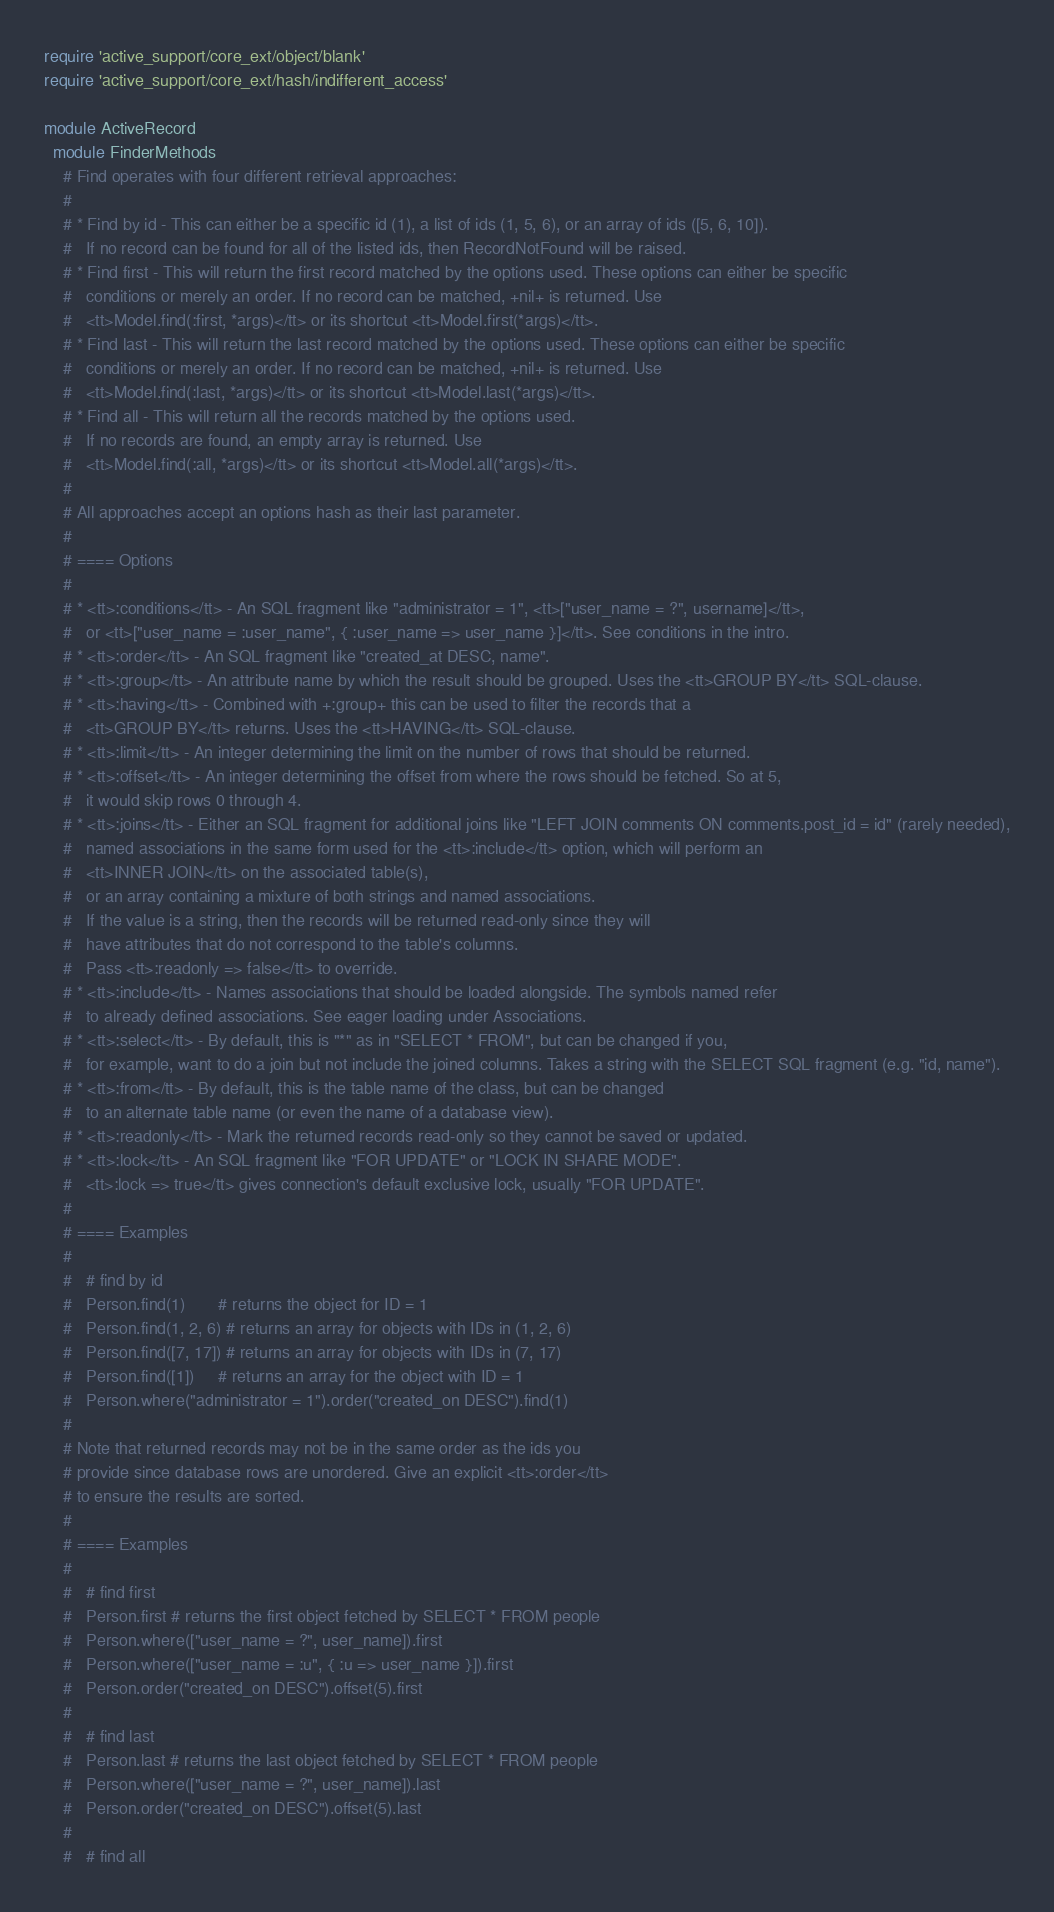<code> <loc_0><loc_0><loc_500><loc_500><_Ruby_>require 'active_support/core_ext/object/blank'
require 'active_support/core_ext/hash/indifferent_access'

module ActiveRecord
  module FinderMethods
    # Find operates with four different retrieval approaches:
    #
    # * Find by id - This can either be a specific id (1), a list of ids (1, 5, 6), or an array of ids ([5, 6, 10]).
    #   If no record can be found for all of the listed ids, then RecordNotFound will be raised.
    # * Find first - This will return the first record matched by the options used. These options can either be specific
    #   conditions or merely an order. If no record can be matched, +nil+ is returned. Use
    #   <tt>Model.find(:first, *args)</tt> or its shortcut <tt>Model.first(*args)</tt>.
    # * Find last - This will return the last record matched by the options used. These options can either be specific
    #   conditions or merely an order. If no record can be matched, +nil+ is returned. Use
    #   <tt>Model.find(:last, *args)</tt> or its shortcut <tt>Model.last(*args)</tt>.
    # * Find all - This will return all the records matched by the options used.
    #   If no records are found, an empty array is returned. Use
    #   <tt>Model.find(:all, *args)</tt> or its shortcut <tt>Model.all(*args)</tt>.
    #
    # All approaches accept an options hash as their last parameter.
    #
    # ==== Options
    #
    # * <tt>:conditions</tt> - An SQL fragment like "administrator = 1", <tt>["user_name = ?", username]</tt>,
    #   or <tt>["user_name = :user_name", { :user_name => user_name }]</tt>. See conditions in the intro.
    # * <tt>:order</tt> - An SQL fragment like "created_at DESC, name".
    # * <tt>:group</tt> - An attribute name by which the result should be grouped. Uses the <tt>GROUP BY</tt> SQL-clause.
    # * <tt>:having</tt> - Combined with +:group+ this can be used to filter the records that a
    #   <tt>GROUP BY</tt> returns. Uses the <tt>HAVING</tt> SQL-clause.
    # * <tt>:limit</tt> - An integer determining the limit on the number of rows that should be returned.
    # * <tt>:offset</tt> - An integer determining the offset from where the rows should be fetched. So at 5,
    #   it would skip rows 0 through 4.
    # * <tt>:joins</tt> - Either an SQL fragment for additional joins like "LEFT JOIN comments ON comments.post_id = id" (rarely needed),
    #   named associations in the same form used for the <tt>:include</tt> option, which will perform an
    #   <tt>INNER JOIN</tt> on the associated table(s),
    #   or an array containing a mixture of both strings and named associations.
    #   If the value is a string, then the records will be returned read-only since they will
    #   have attributes that do not correspond to the table's columns.
    #   Pass <tt>:readonly => false</tt> to override.
    # * <tt>:include</tt> - Names associations that should be loaded alongside. The symbols named refer
    #   to already defined associations. See eager loading under Associations.
    # * <tt>:select</tt> - By default, this is "*" as in "SELECT * FROM", but can be changed if you,
    #   for example, want to do a join but not include the joined columns. Takes a string with the SELECT SQL fragment (e.g. "id, name").
    # * <tt>:from</tt> - By default, this is the table name of the class, but can be changed
    #   to an alternate table name (or even the name of a database view).
    # * <tt>:readonly</tt> - Mark the returned records read-only so they cannot be saved or updated.
    # * <tt>:lock</tt> - An SQL fragment like "FOR UPDATE" or "LOCK IN SHARE MODE".
    #   <tt>:lock => true</tt> gives connection's default exclusive lock, usually "FOR UPDATE".
    #
    # ==== Examples
    #
    #   # find by id
    #   Person.find(1)       # returns the object for ID = 1
    #   Person.find(1, 2, 6) # returns an array for objects with IDs in (1, 2, 6)
    #   Person.find([7, 17]) # returns an array for objects with IDs in (7, 17)
    #   Person.find([1])     # returns an array for the object with ID = 1
    #   Person.where("administrator = 1").order("created_on DESC").find(1)
    #
    # Note that returned records may not be in the same order as the ids you
    # provide since database rows are unordered. Give an explicit <tt>:order</tt>
    # to ensure the results are sorted.
    #
    # ==== Examples
    #
    #   # find first
    #   Person.first # returns the first object fetched by SELECT * FROM people
    #   Person.where(["user_name = ?", user_name]).first
    #   Person.where(["user_name = :u", { :u => user_name }]).first
    #   Person.order("created_on DESC").offset(5).first
    #
    #   # find last
    #   Person.last # returns the last object fetched by SELECT * FROM people
    #   Person.where(["user_name = ?", user_name]).last
    #   Person.order("created_on DESC").offset(5).last
    #
    #   # find all</code> 